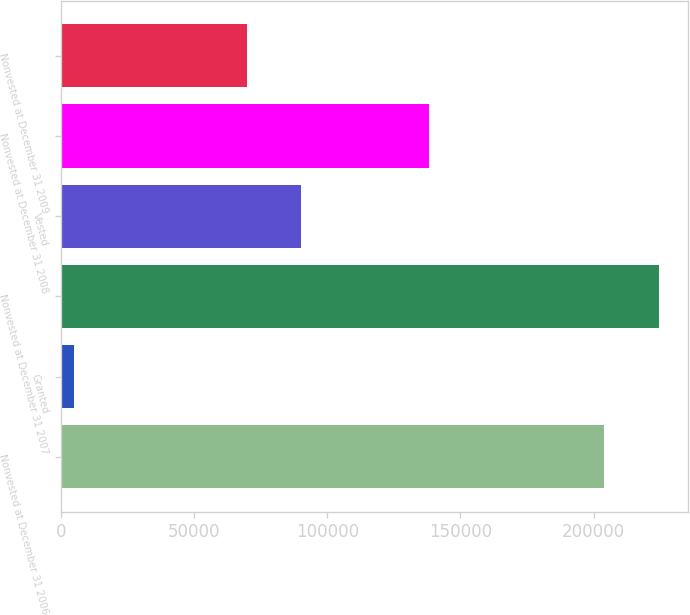<chart> <loc_0><loc_0><loc_500><loc_500><bar_chart><fcel>Nonvested at December 31 2006<fcel>Granted<fcel>Nonvested at December 31 2007<fcel>Vested<fcel>Nonvested at December 31 2008<fcel>Nonvested at December 31 2009<nl><fcel>204000<fcel>4800<fcel>224400<fcel>90266<fcel>138130<fcel>69866<nl></chart> 